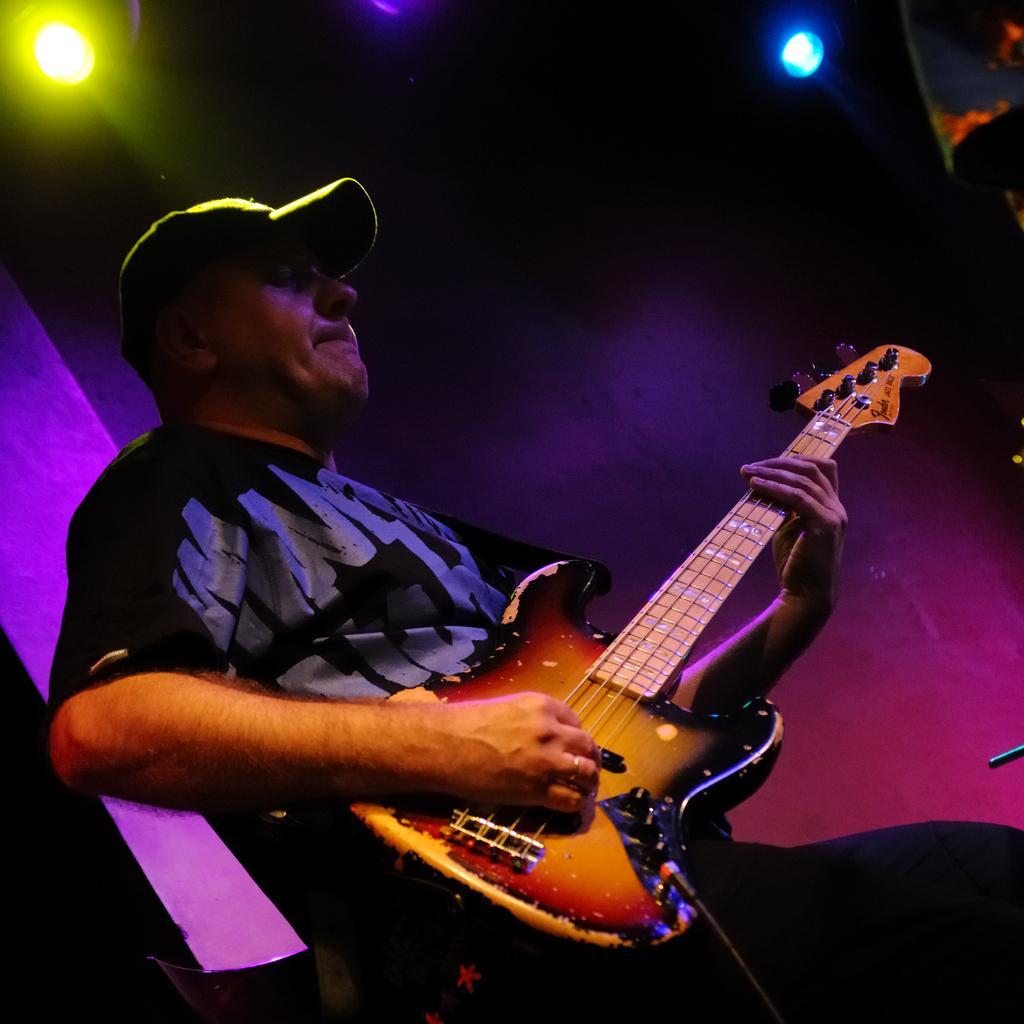Could you give a brief overview of what you see in this image? There is a man who is playing guitar. He wear a cap. On the background there are lights. 